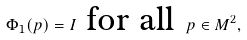<formula> <loc_0><loc_0><loc_500><loc_500>\Phi _ { 1 } ( p ) = I \text { for all } p \in M ^ { 2 } ,</formula> 